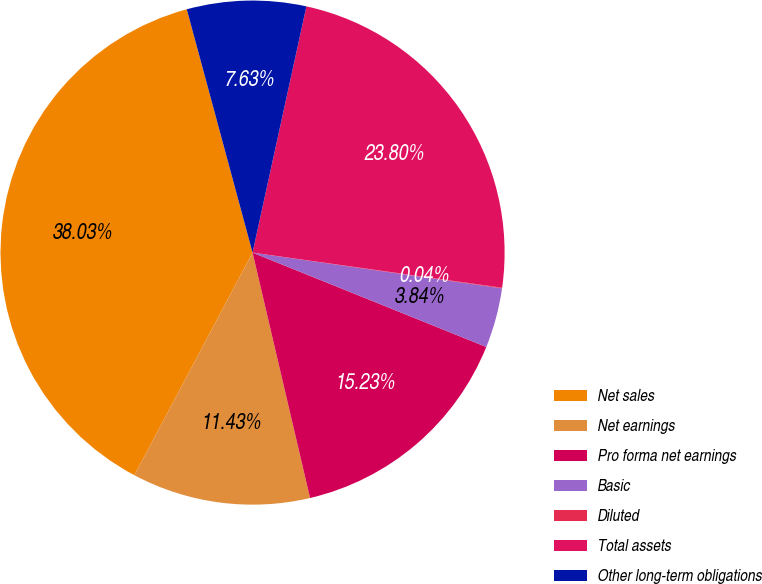<chart> <loc_0><loc_0><loc_500><loc_500><pie_chart><fcel>Net sales<fcel>Net earnings<fcel>Pro forma net earnings<fcel>Basic<fcel>Diluted<fcel>Total assets<fcel>Other long-term obligations<nl><fcel>38.03%<fcel>11.43%<fcel>15.23%<fcel>3.84%<fcel>0.04%<fcel>23.8%<fcel>7.63%<nl></chart> 